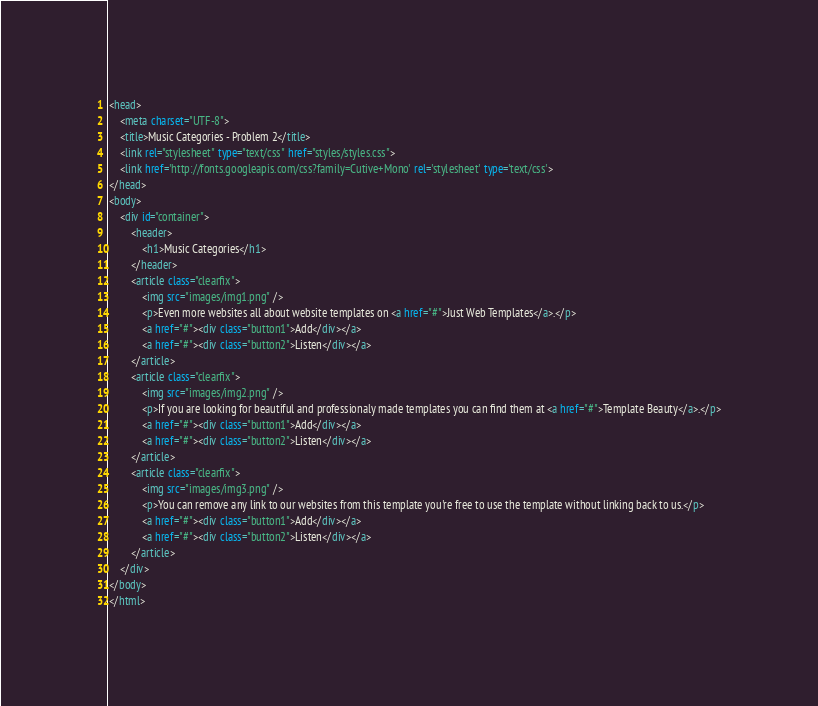<code> <loc_0><loc_0><loc_500><loc_500><_HTML_><head>
	<meta charset="UTF-8">
	<title>Music Categories - Problem 2</title>
	<link rel="stylesheet" type="text/css" href="styles/styles.css">
	<link href='http://fonts.googleapis.com/css?family=Cutive+Mono' rel='stylesheet' type='text/css'>
</head>
<body>
    <div id="container">
        <header>
            <h1>Music Categories</h1>
        </header>
        <article class="clearfix">
            <img src="images/img1.png" />
            <p>Even more websites all about website templates on <a href="#">Just Web Templates</a>.</p>
            <a href="#"><div class="button1">Add</div></a>
            <a href="#"><div class="button2">Listen</div></a>
        </article>
        <article class="clearfix">
            <img src="images/img2.png" />
            <p>If you are looking for beautiful and professionaly made templates you can find them at <a href="#">Template Beauty</a>.</p>
            <a href="#"><div class="button1">Add</div></a>
            <a href="#"><div class="button2">Listen</div></a>
        </article>
        <article class="clearfix">
            <img src="images/img3.png" />
            <p>You can remove any link to our websites from this template you're free to use the template without linking back to us.</p>
            <a href="#"><div class="button1">Add</div></a>
            <a href="#"><div class="button2">Listen</div></a>
        </article>
    </div>
</body>
</html></code> 